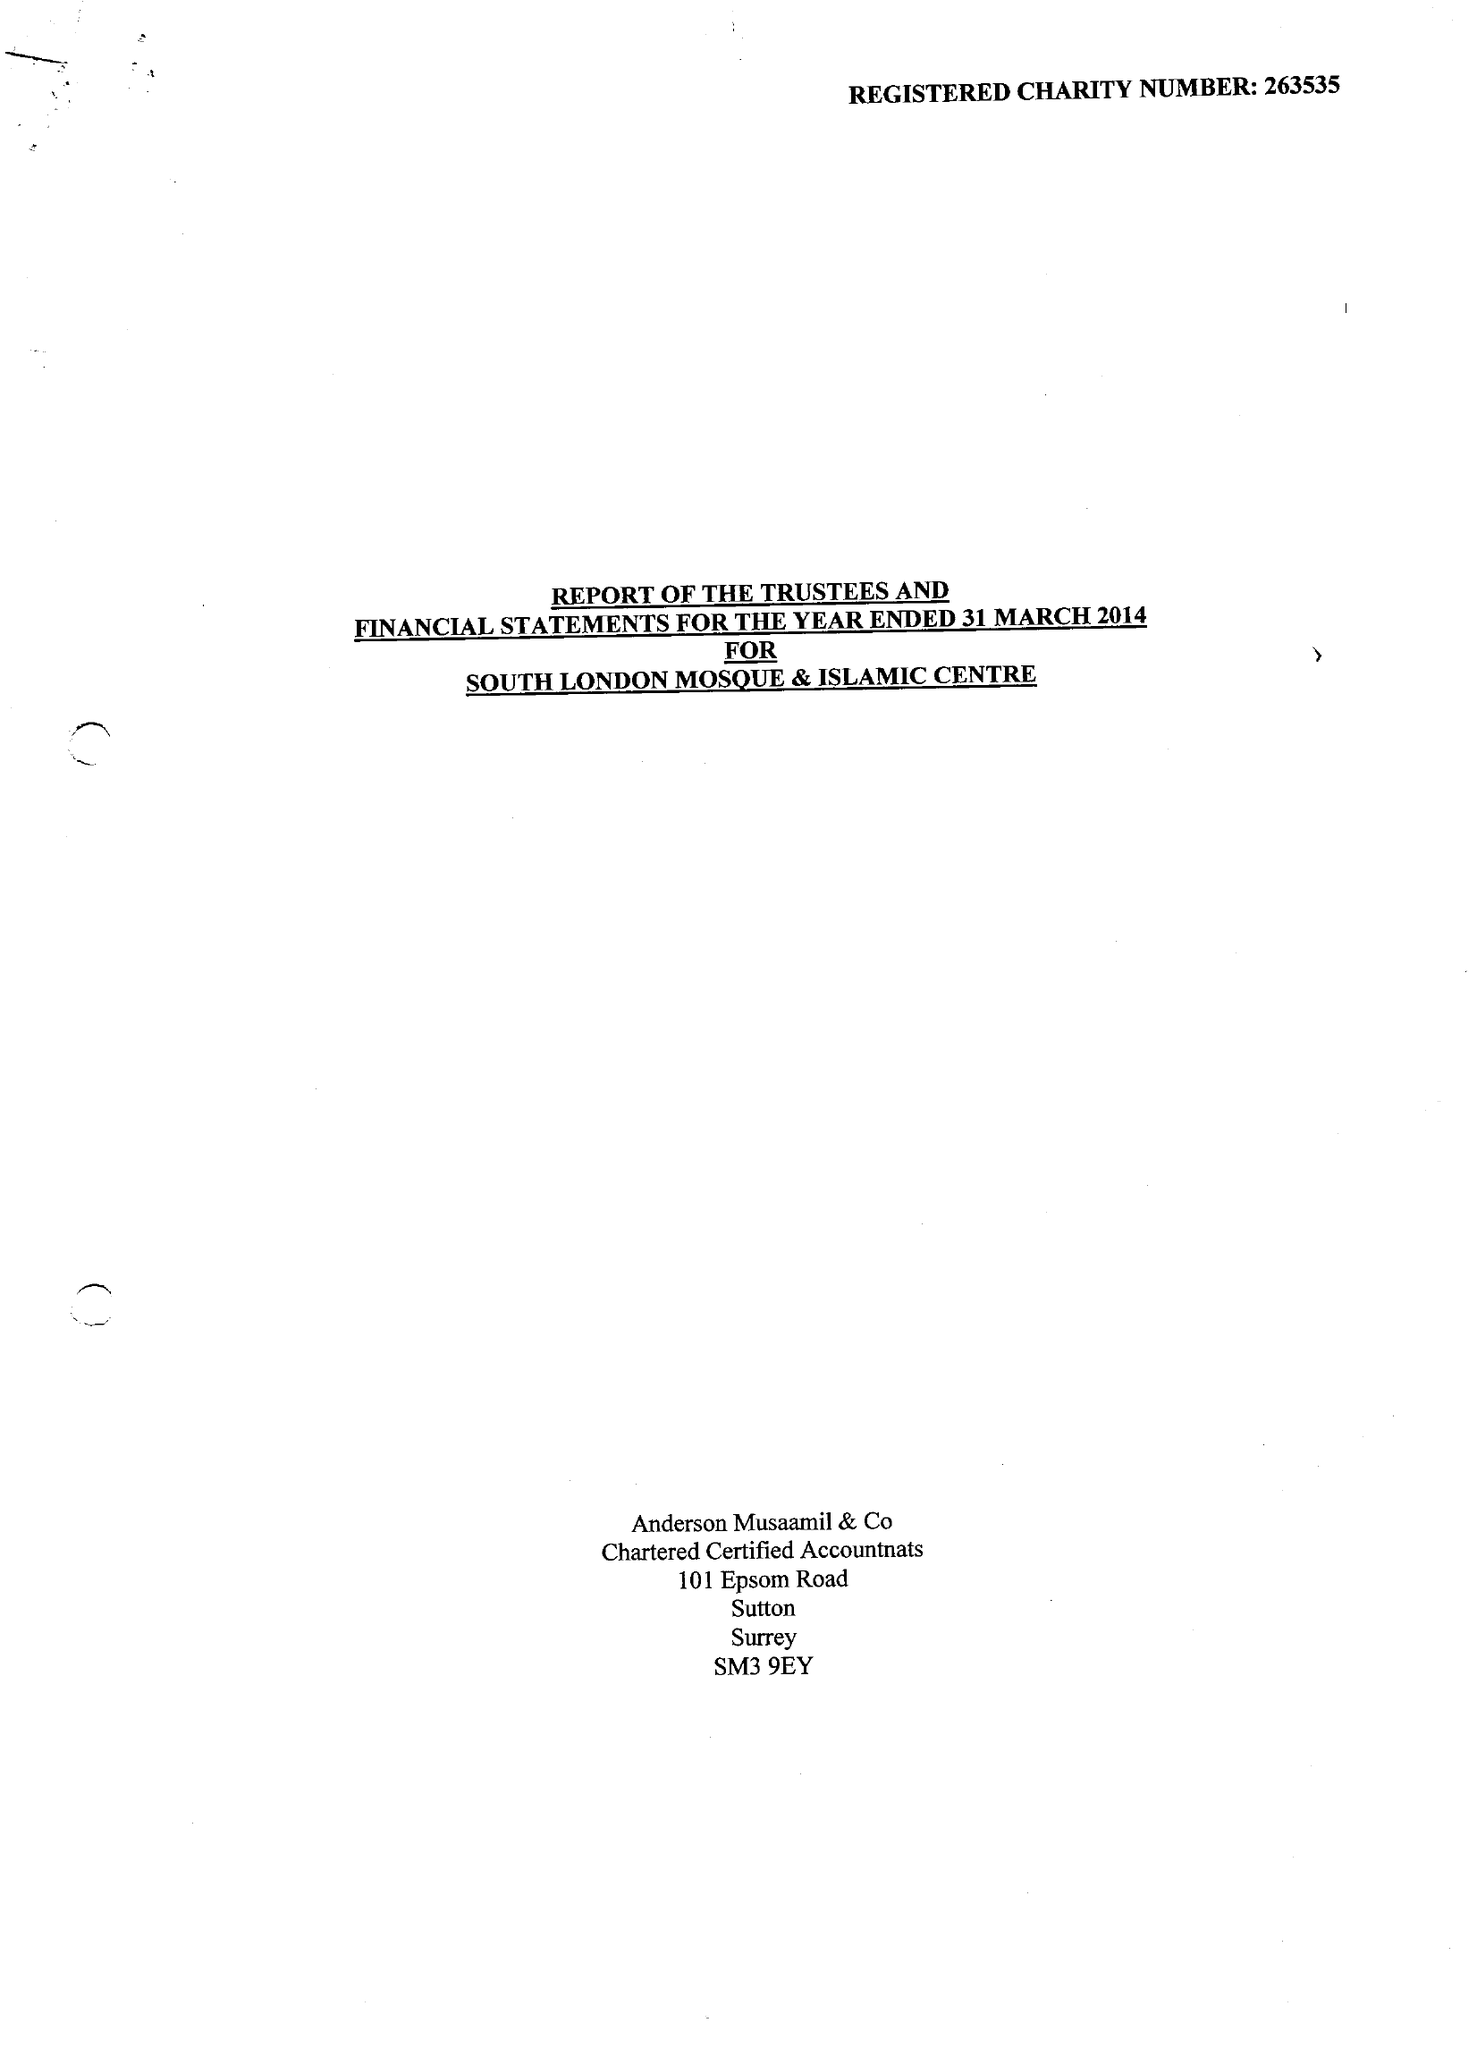What is the value for the report_date?
Answer the question using a single word or phrase. 2014-03-31 